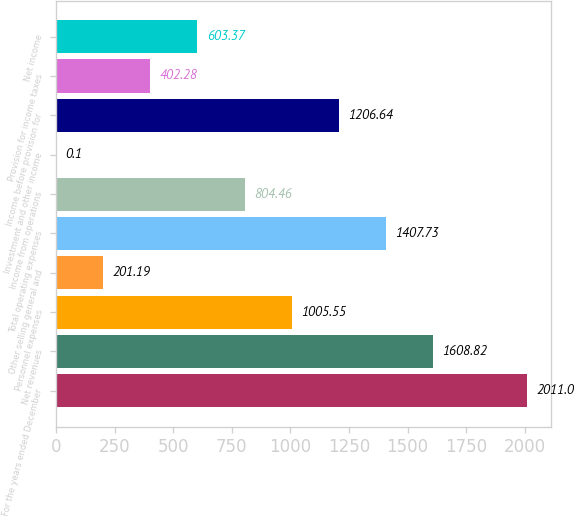Convert chart. <chart><loc_0><loc_0><loc_500><loc_500><bar_chart><fcel>For the years ended December<fcel>Net revenues<fcel>Personnel expenses<fcel>Other selling general and<fcel>Total operating expenses<fcel>Income from operations<fcel>Investment and other income<fcel>Income before provision for<fcel>Provision for income taxes<fcel>Net income<nl><fcel>2011<fcel>1608.82<fcel>1005.55<fcel>201.19<fcel>1407.73<fcel>804.46<fcel>0.1<fcel>1206.64<fcel>402.28<fcel>603.37<nl></chart> 